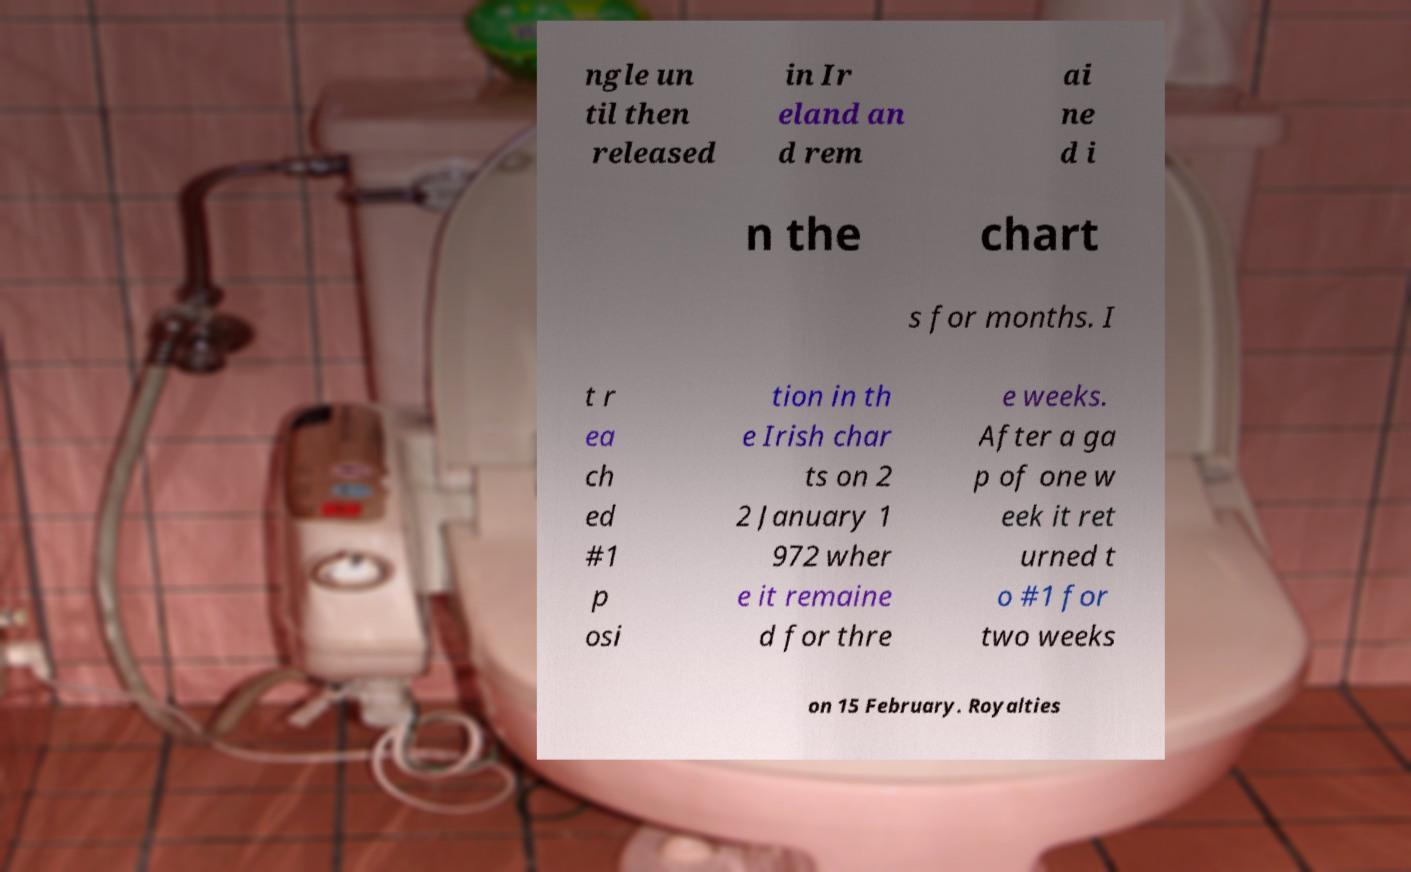Could you extract and type out the text from this image? ngle un til then released in Ir eland an d rem ai ne d i n the chart s for months. I t r ea ch ed #1 p osi tion in th e Irish char ts on 2 2 January 1 972 wher e it remaine d for thre e weeks. After a ga p of one w eek it ret urned t o #1 for two weeks on 15 February. Royalties 